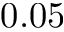Convert formula to latex. <formula><loc_0><loc_0><loc_500><loc_500>0 . 0 5</formula> 